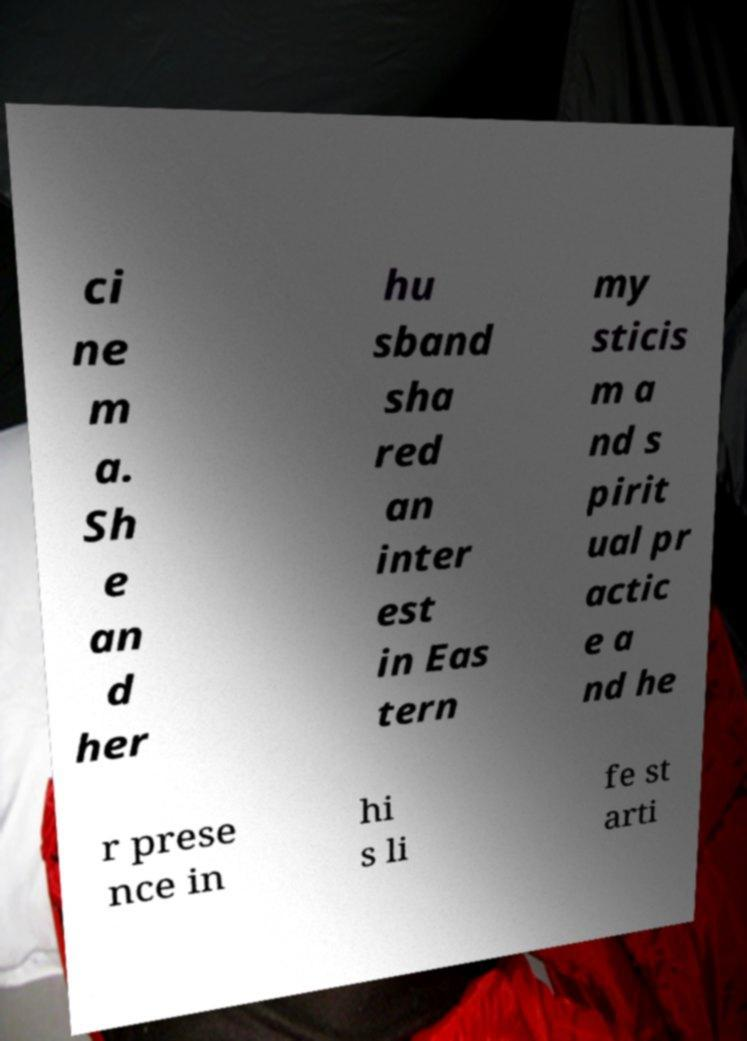For documentation purposes, I need the text within this image transcribed. Could you provide that? ci ne m a. Sh e an d her hu sband sha red an inter est in Eas tern my sticis m a nd s pirit ual pr actic e a nd he r prese nce in hi s li fe st arti 